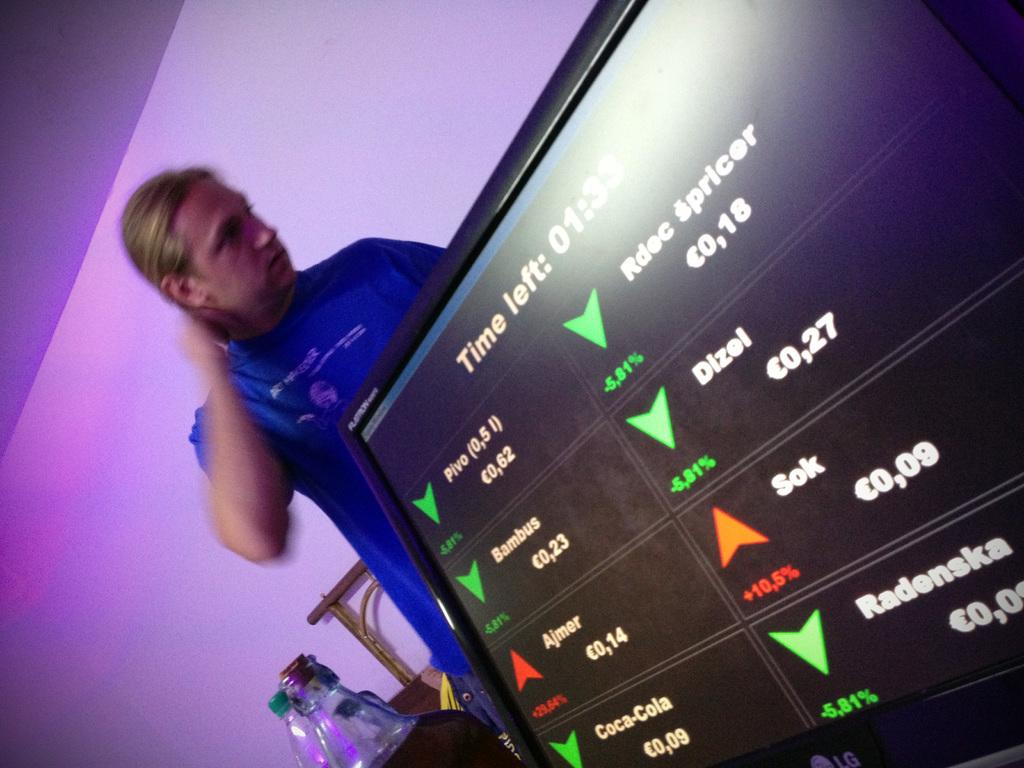<image>
Render a clear and concise summary of the photo. a man next to a tv that has time left on it 